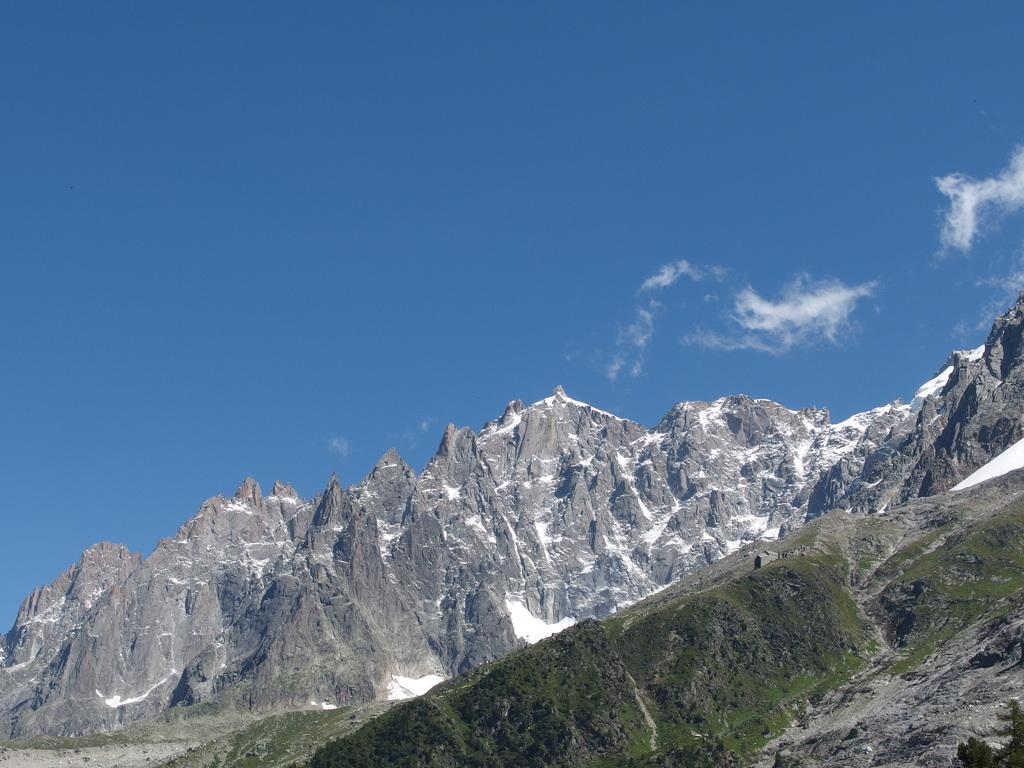What type of natural formation can be seen in the image? There are mountains in the image. What is covering the ground in the image? There is snow and grass in the image. What is visible in the sky in the image? The sky is visible in the image, and there are clouds present. Can you tell me the rate at which the snake is slithering in the image? There is no snake present in the image, so it is not possible to determine its rate of movement. How many people can be seen in the image? There is no person present in the image; it features mountains, snow, grass, and clouds. 